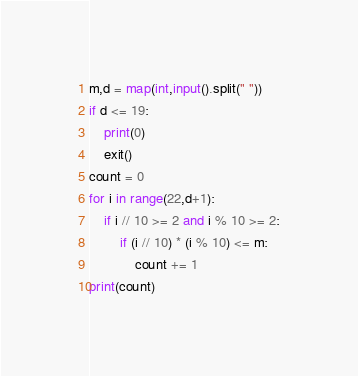<code> <loc_0><loc_0><loc_500><loc_500><_Python_>m,d = map(int,input().split(" "))
if d <= 19:
    print(0)
    exit()
count = 0
for i in range(22,d+1):
    if i // 10 >= 2 and i % 10 >= 2:
        if (i // 10) * (i % 10) <= m:
            count += 1
print(count)</code> 